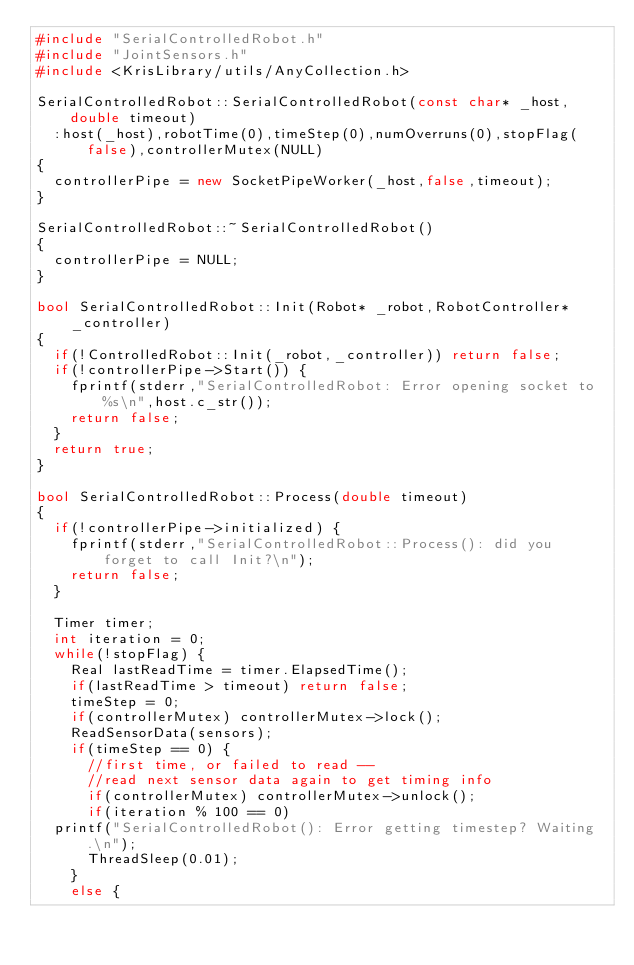<code> <loc_0><loc_0><loc_500><loc_500><_C++_>#include "SerialControlledRobot.h"
#include "JointSensors.h"
#include <KrisLibrary/utils/AnyCollection.h>

SerialControlledRobot::SerialControlledRobot(const char* _host,double timeout)
  :host(_host),robotTime(0),timeStep(0),numOverruns(0),stopFlag(false),controllerMutex(NULL)
{
  controllerPipe = new SocketPipeWorker(_host,false,timeout);
}

SerialControlledRobot::~SerialControlledRobot()
{
  controllerPipe = NULL;
}

bool SerialControlledRobot::Init(Robot* _robot,RobotController* _controller)
{
  if(!ControlledRobot::Init(_robot,_controller)) return false;
  if(!controllerPipe->Start()) {
    fprintf(stderr,"SerialControlledRobot: Error opening socket to %s\n",host.c_str());
    return false;
  }
  return true;
}

bool SerialControlledRobot::Process(double timeout)
{
  if(!controllerPipe->initialized) {
    fprintf(stderr,"SerialControlledRobot::Process(): did you forget to call Init?\n");
    return false;
  }

  Timer timer;
  int iteration = 0;
  while(!stopFlag) {
    Real lastReadTime = timer.ElapsedTime();
    if(lastReadTime > timeout) return false;
    timeStep = 0;
    if(controllerMutex) controllerMutex->lock();
    ReadSensorData(sensors);
    if(timeStep == 0) {
      //first time, or failed to read -- 
      //read next sensor data again to get timing info
      if(controllerMutex) controllerMutex->unlock();
      if(iteration % 100 == 0)
	printf("SerialControlledRobot(): Error getting timestep? Waiting.\n");
      ThreadSleep(0.01);
    }
    else {</code> 